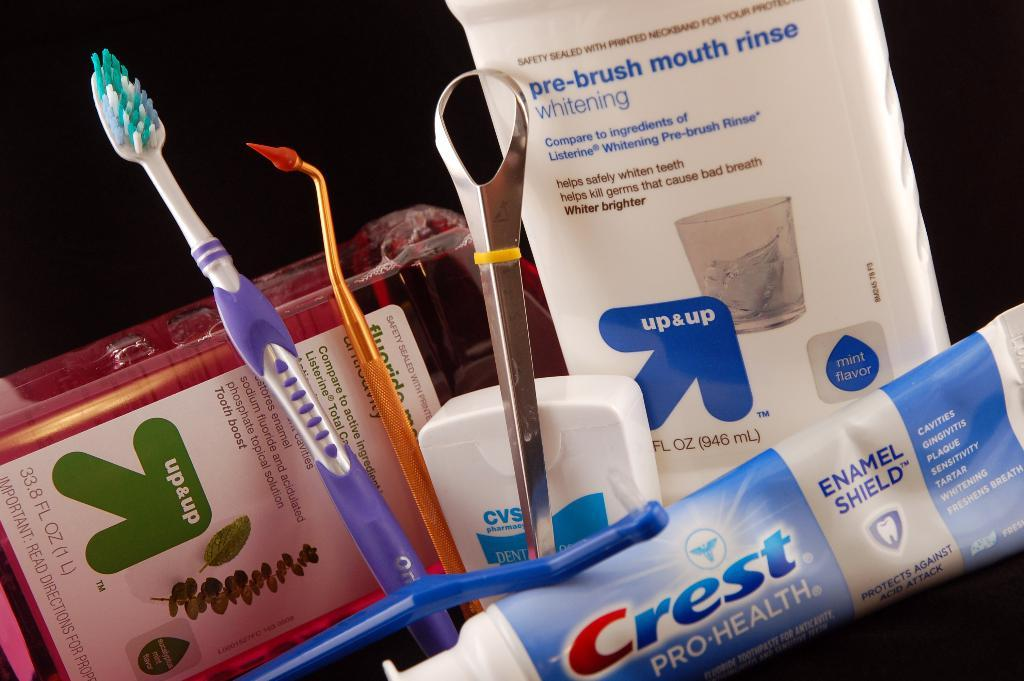<image>
Render a clear and concise summary of the photo. A collection of dental maintenance equipment with a tube of crest pro health toothpaste on the bottom. 